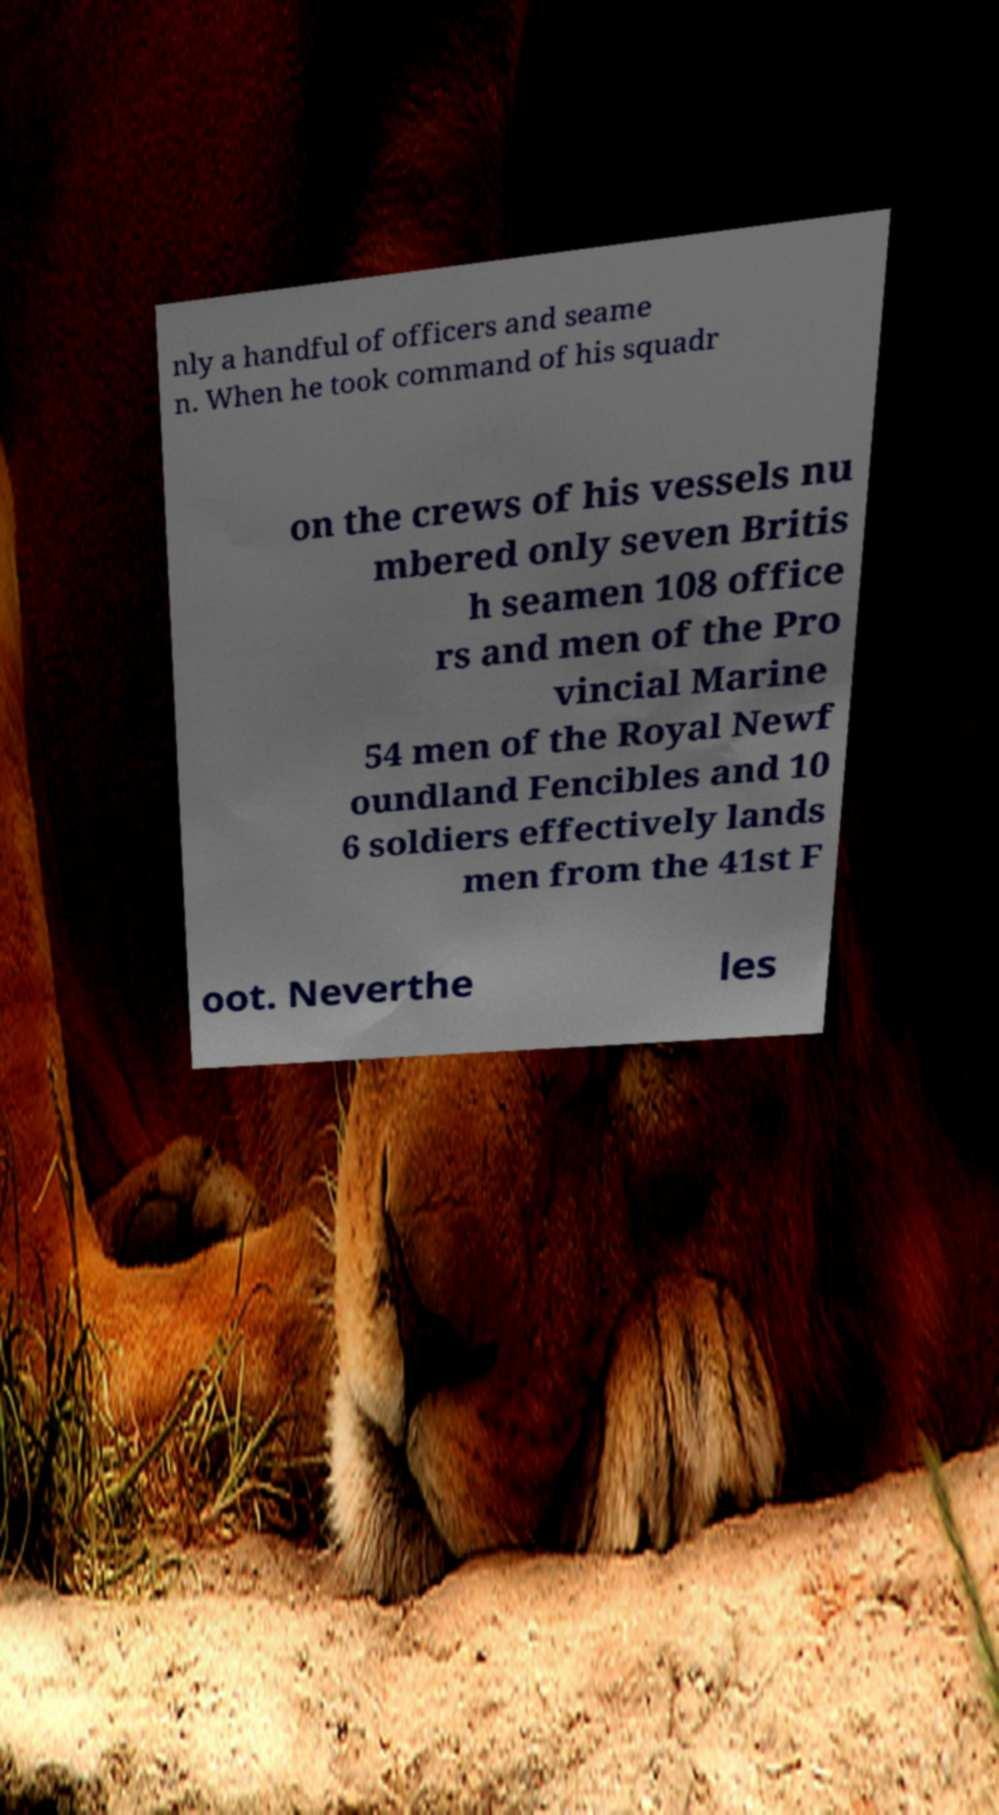Please read and relay the text visible in this image. What does it say? nly a handful of officers and seame n. When he took command of his squadr on the crews of his vessels nu mbered only seven Britis h seamen 108 office rs and men of the Pro vincial Marine 54 men of the Royal Newf oundland Fencibles and 10 6 soldiers effectively lands men from the 41st F oot. Neverthe les 